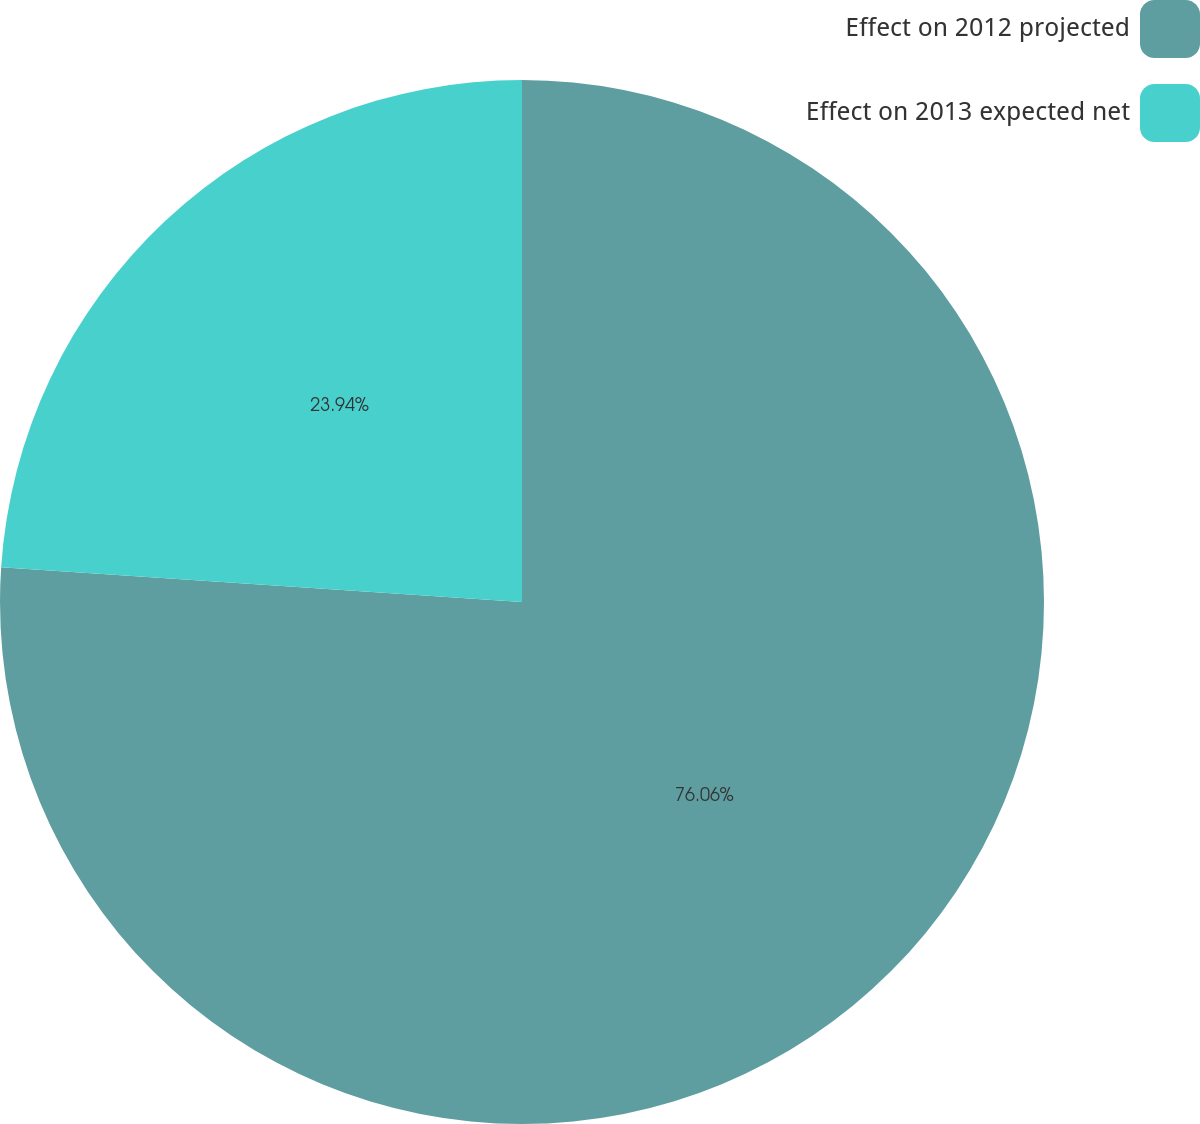Convert chart to OTSL. <chart><loc_0><loc_0><loc_500><loc_500><pie_chart><fcel>Effect on 2012 projected<fcel>Effect on 2013 expected net<nl><fcel>76.06%<fcel>23.94%<nl></chart> 